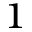<formula> <loc_0><loc_0><loc_500><loc_500>^ { 1 }</formula> 